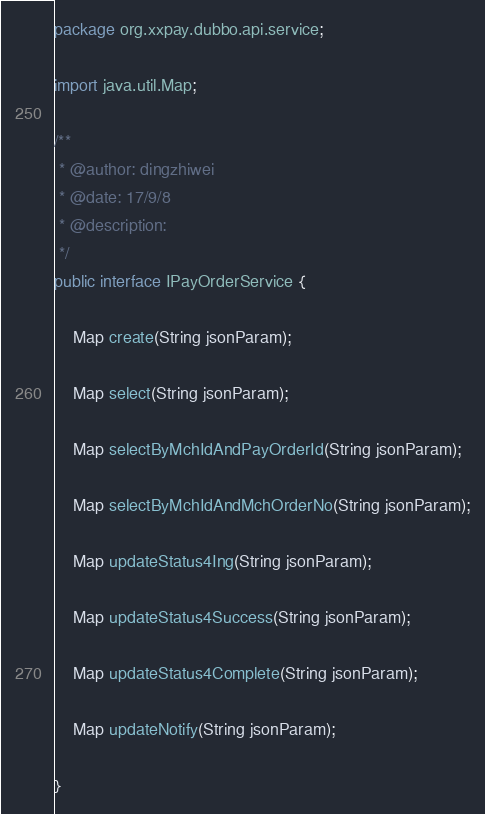Convert code to text. <code><loc_0><loc_0><loc_500><loc_500><_Java_>package org.xxpay.dubbo.api.service;

import java.util.Map;

/**
 * @author: dingzhiwei
 * @date: 17/9/8
 * @description:
 */
public interface IPayOrderService {

    Map create(String jsonParam);

    Map select(String jsonParam);

    Map selectByMchIdAndPayOrderId(String jsonParam);

    Map selectByMchIdAndMchOrderNo(String jsonParam);

    Map updateStatus4Ing(String jsonParam);

    Map updateStatus4Success(String jsonParam);

    Map updateStatus4Complete(String jsonParam);

    Map updateNotify(String jsonParam);

}
</code> 